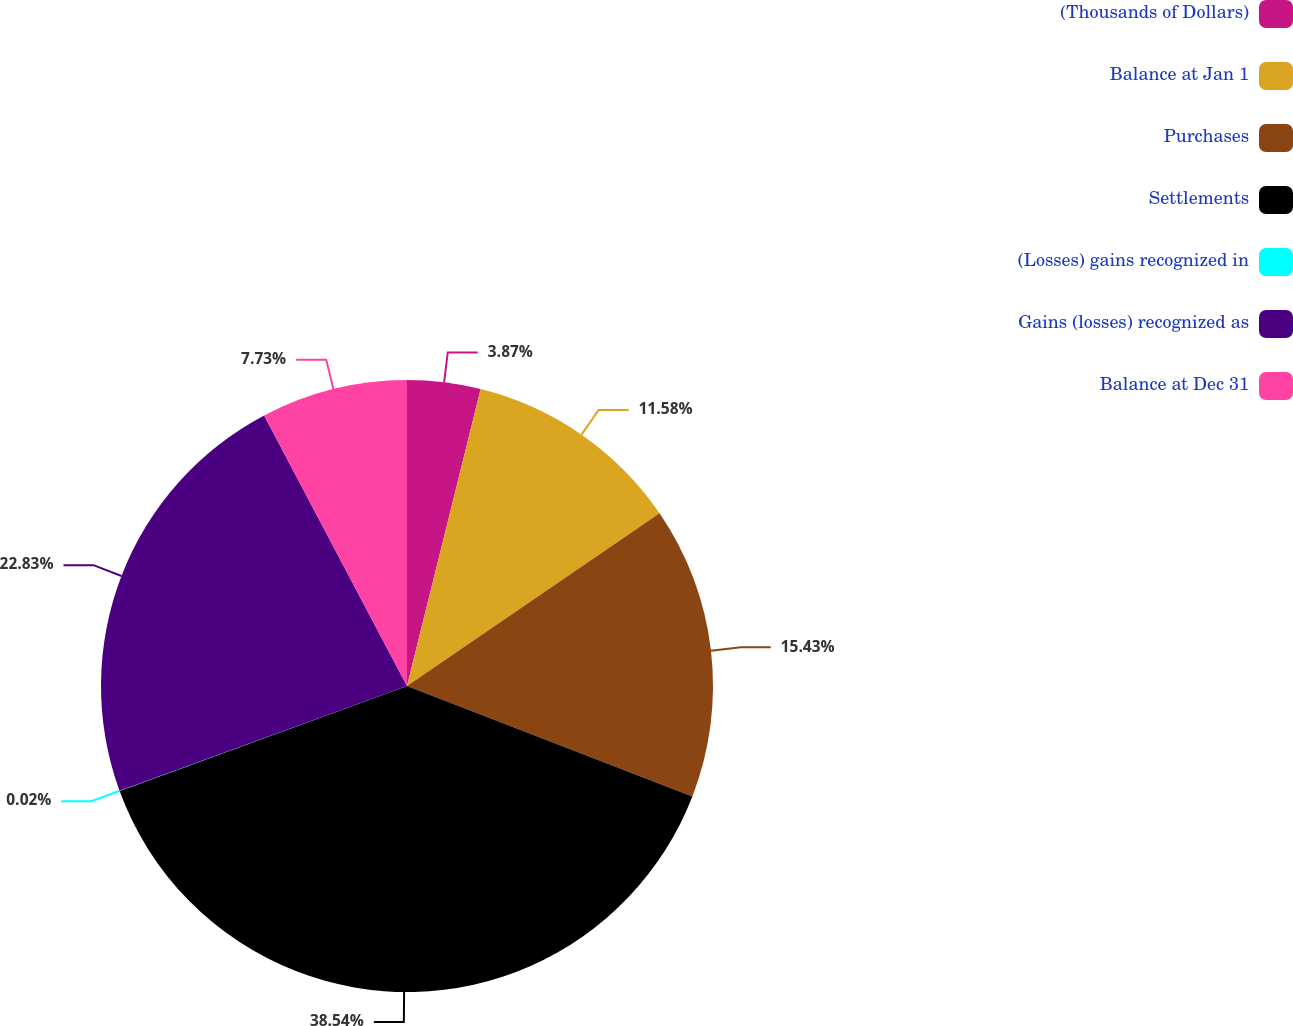Convert chart to OTSL. <chart><loc_0><loc_0><loc_500><loc_500><pie_chart><fcel>(Thousands of Dollars)<fcel>Balance at Jan 1<fcel>Purchases<fcel>Settlements<fcel>(Losses) gains recognized in<fcel>Gains (losses) recognized as<fcel>Balance at Dec 31<nl><fcel>3.87%<fcel>11.58%<fcel>15.43%<fcel>38.54%<fcel>0.02%<fcel>22.83%<fcel>7.73%<nl></chart> 